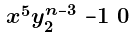Convert formula to latex. <formula><loc_0><loc_0><loc_500><loc_500>\begin{smallmatrix} x ^ { 5 } y _ { 2 } ^ { n - 3 } & - 1 & 0 \end{smallmatrix}</formula> 